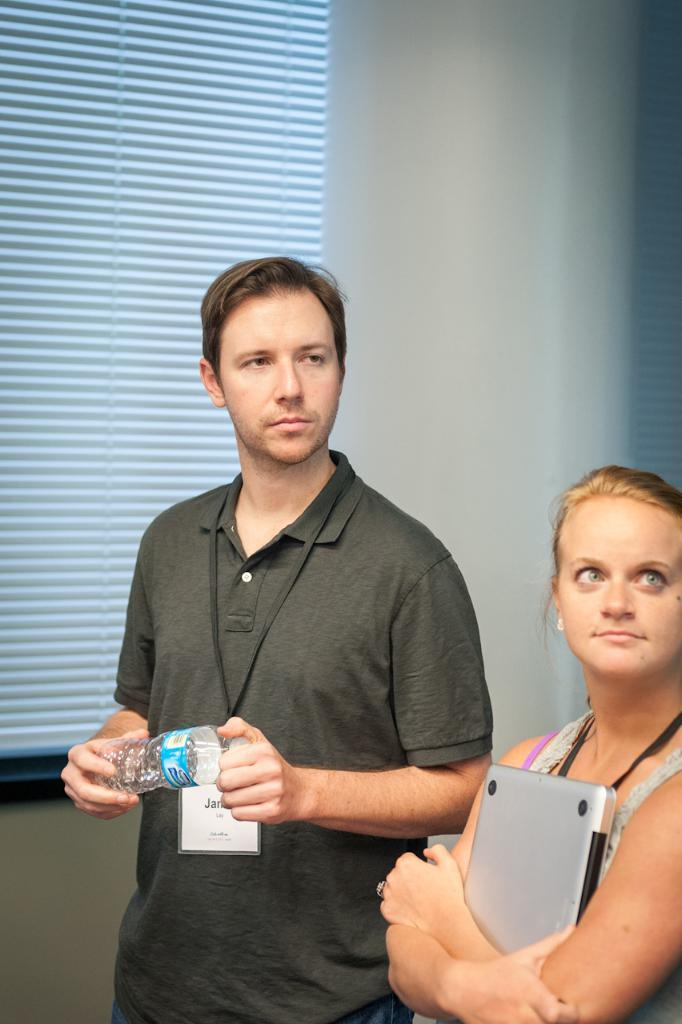How many people are in the image? There are two people in the image. Can you describe the gender of each person? The person on the right side is a woman, and the person on the left side is a man. What is the man holding in his hand? The man is holding a bottle in his hand. What is the woman holding? The woman is holding a laptop. What type of grass can be seen growing in the image? There is no grass present in the image. What word is being spelled out by the people in the image? There are no words being spelled out by the people in the image. 